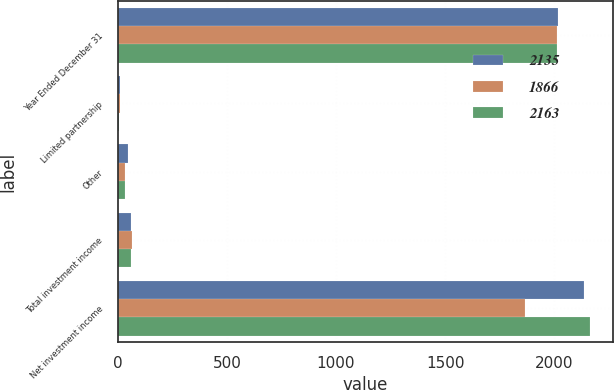Convert chart. <chart><loc_0><loc_0><loc_500><loc_500><stacked_bar_chart><ecel><fcel>Year Ended December 31<fcel>Limited partnership<fcel>Other<fcel>Total investment income<fcel>Net investment income<nl><fcel>2135<fcel>2016<fcel>9<fcel>45<fcel>59<fcel>2135<nl><fcel>1866<fcel>2015<fcel>11<fcel>34<fcel>63<fcel>1866<nl><fcel>2163<fcel>2014<fcel>4<fcel>34<fcel>58<fcel>2163<nl></chart> 